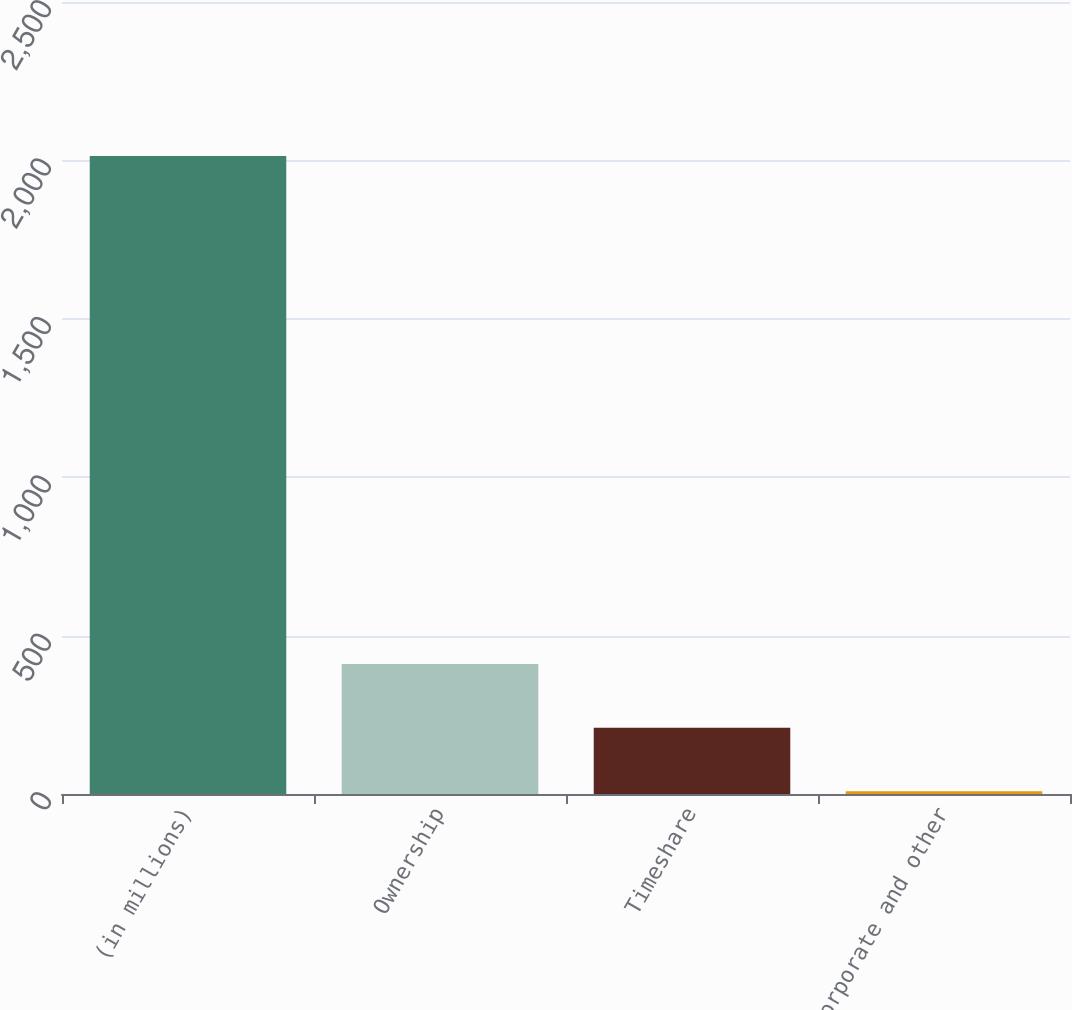Convert chart to OTSL. <chart><loc_0><loc_0><loc_500><loc_500><bar_chart><fcel>(in millions)<fcel>Ownership<fcel>Timeshare<fcel>Corporate and other<nl><fcel>2014<fcel>410<fcel>209.5<fcel>9<nl></chart> 